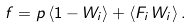Convert formula to latex. <formula><loc_0><loc_0><loc_500><loc_500>f = p \, \langle 1 - W _ { i } \rangle + \langle F _ { i } \, W _ { i } \rangle \, .</formula> 